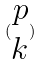Convert formula to latex. <formula><loc_0><loc_0><loc_500><loc_500>( \begin{matrix} p \\ k \end{matrix} )</formula> 